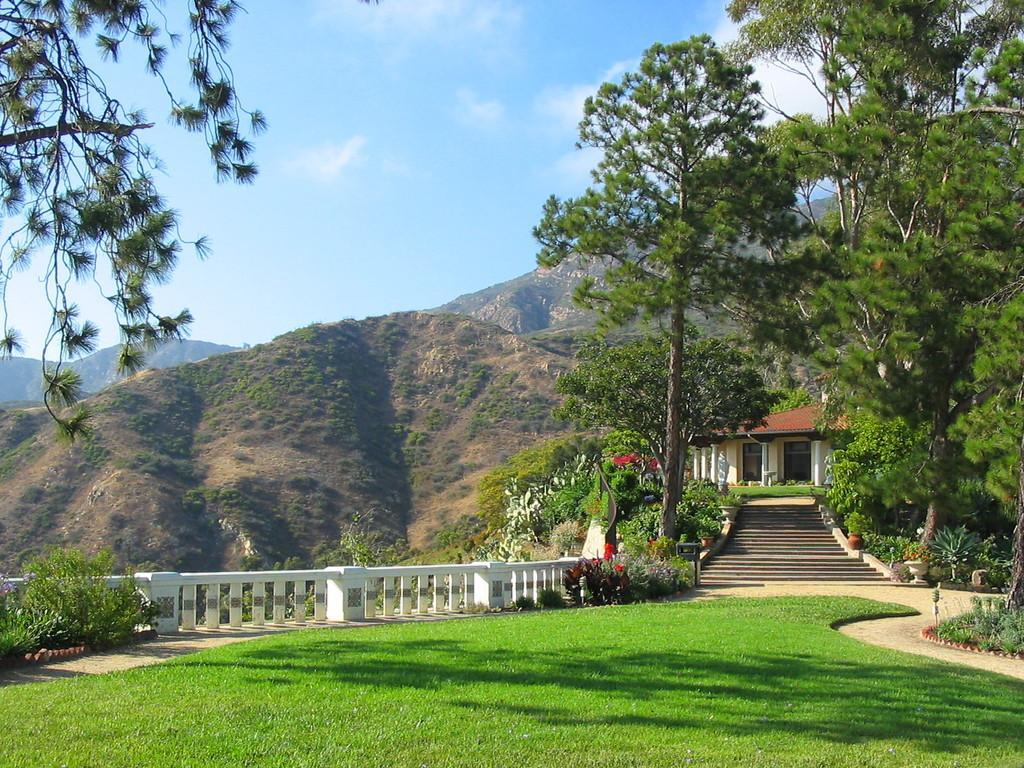Can you describe this image briefly? In the picture we can see a scenery with the hills, trees, house with steps and railing near to it and a grass surface and in the background we can see a sky and clouds. 